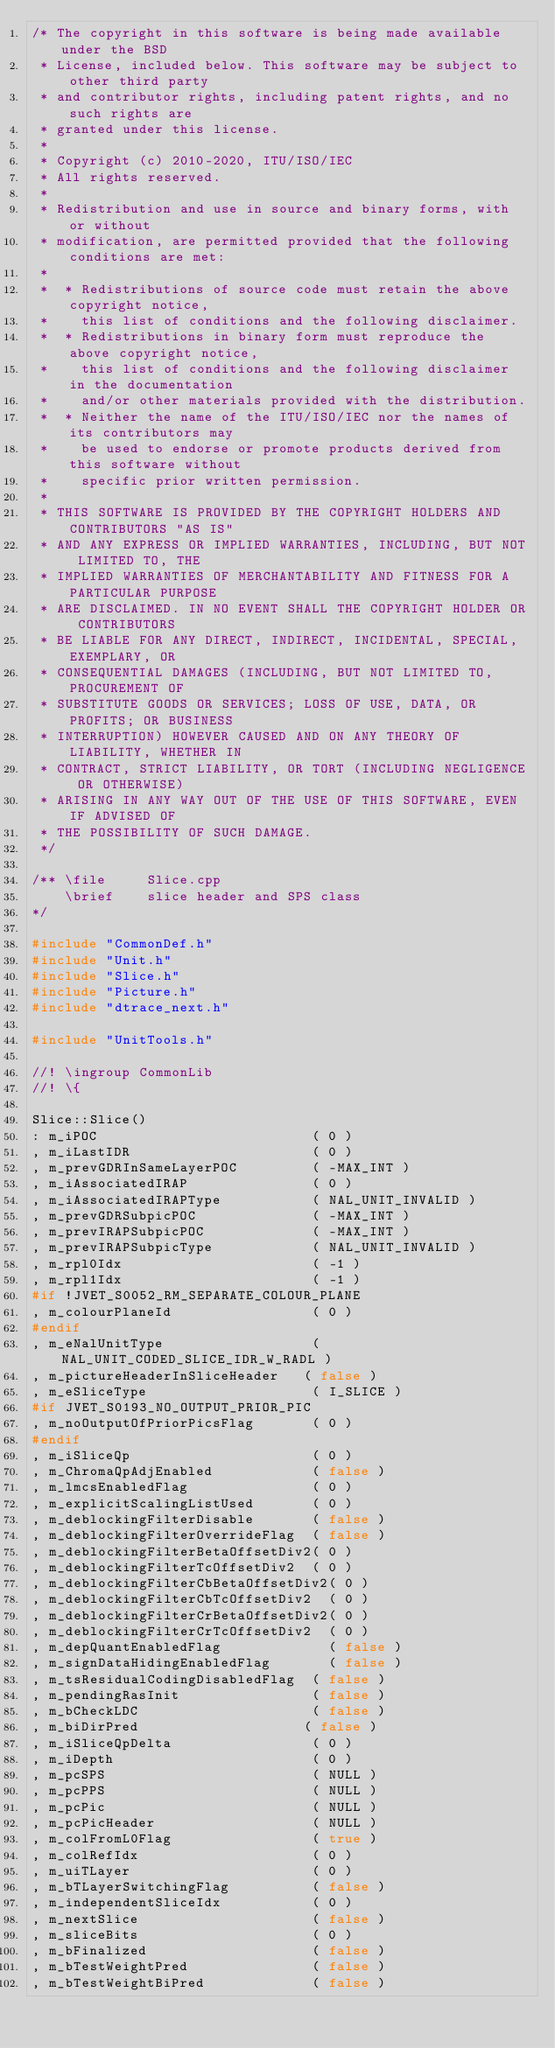<code> <loc_0><loc_0><loc_500><loc_500><_C++_>/* The copyright in this software is being made available under the BSD
 * License, included below. This software may be subject to other third party
 * and contributor rights, including patent rights, and no such rights are
 * granted under this license.
 *
 * Copyright (c) 2010-2020, ITU/ISO/IEC
 * All rights reserved.
 *
 * Redistribution and use in source and binary forms, with or without
 * modification, are permitted provided that the following conditions are met:
 *
 *  * Redistributions of source code must retain the above copyright notice,
 *    this list of conditions and the following disclaimer.
 *  * Redistributions in binary form must reproduce the above copyright notice,
 *    this list of conditions and the following disclaimer in the documentation
 *    and/or other materials provided with the distribution.
 *  * Neither the name of the ITU/ISO/IEC nor the names of its contributors may
 *    be used to endorse or promote products derived from this software without
 *    specific prior written permission.
 *
 * THIS SOFTWARE IS PROVIDED BY THE COPYRIGHT HOLDERS AND CONTRIBUTORS "AS IS"
 * AND ANY EXPRESS OR IMPLIED WARRANTIES, INCLUDING, BUT NOT LIMITED TO, THE
 * IMPLIED WARRANTIES OF MERCHANTABILITY AND FITNESS FOR A PARTICULAR PURPOSE
 * ARE DISCLAIMED. IN NO EVENT SHALL THE COPYRIGHT HOLDER OR CONTRIBUTORS
 * BE LIABLE FOR ANY DIRECT, INDIRECT, INCIDENTAL, SPECIAL, EXEMPLARY, OR
 * CONSEQUENTIAL DAMAGES (INCLUDING, BUT NOT LIMITED TO, PROCUREMENT OF
 * SUBSTITUTE GOODS OR SERVICES; LOSS OF USE, DATA, OR PROFITS; OR BUSINESS
 * INTERRUPTION) HOWEVER CAUSED AND ON ANY THEORY OF LIABILITY, WHETHER IN
 * CONTRACT, STRICT LIABILITY, OR TORT (INCLUDING NEGLIGENCE OR OTHERWISE)
 * ARISING IN ANY WAY OUT OF THE USE OF THIS SOFTWARE, EVEN IF ADVISED OF
 * THE POSSIBILITY OF SUCH DAMAGE.
 */

/** \file     Slice.cpp
    \brief    slice header and SPS class
*/

#include "CommonDef.h"
#include "Unit.h"
#include "Slice.h"
#include "Picture.h"
#include "dtrace_next.h"

#include "UnitTools.h"

//! \ingroup CommonLib
//! \{

Slice::Slice()
: m_iPOC                          ( 0 )
, m_iLastIDR                      ( 0 )
, m_prevGDRInSameLayerPOC         ( -MAX_INT )
, m_iAssociatedIRAP               ( 0 )
, m_iAssociatedIRAPType           ( NAL_UNIT_INVALID )
, m_prevGDRSubpicPOC              ( -MAX_INT )
, m_prevIRAPSubpicPOC             ( -MAX_INT )
, m_prevIRAPSubpicType            ( NAL_UNIT_INVALID )
, m_rpl0Idx                       ( -1 )
, m_rpl1Idx                       ( -1 )
#if !JVET_S0052_RM_SEPARATE_COLOUR_PLANE
, m_colourPlaneId                 ( 0 )
#endif
, m_eNalUnitType                  ( NAL_UNIT_CODED_SLICE_IDR_W_RADL )
, m_pictureHeaderInSliceHeader   ( false )
, m_eSliceType                    ( I_SLICE )
#if JVET_S0193_NO_OUTPUT_PRIOR_PIC
, m_noOutputOfPriorPicsFlag       ( 0 )
#endif
, m_iSliceQp                      ( 0 )
, m_ChromaQpAdjEnabled            ( false )
, m_lmcsEnabledFlag               ( 0 )
, m_explicitScalingListUsed       ( 0 )
, m_deblockingFilterDisable       ( false )
, m_deblockingFilterOverrideFlag  ( false )
, m_deblockingFilterBetaOffsetDiv2( 0 )
, m_deblockingFilterTcOffsetDiv2  ( 0 )
, m_deblockingFilterCbBetaOffsetDiv2( 0 )
, m_deblockingFilterCbTcOffsetDiv2  ( 0 )
, m_deblockingFilterCrBetaOffsetDiv2( 0 )
, m_deblockingFilterCrTcOffsetDiv2  ( 0 )
, m_depQuantEnabledFlag             ( false )
, m_signDataHidingEnabledFlag       ( false )
, m_tsResidualCodingDisabledFlag  ( false )
, m_pendingRasInit                ( false )
, m_bCheckLDC                     ( false )
, m_biDirPred                    ( false )
, m_iSliceQpDelta                 ( 0 )
, m_iDepth                        ( 0 )
, m_pcSPS                         ( NULL )
, m_pcPPS                         ( NULL )
, m_pcPic                         ( NULL )
, m_pcPicHeader                   ( NULL )
, m_colFromL0Flag                 ( true )
, m_colRefIdx                     ( 0 )
, m_uiTLayer                      ( 0 )
, m_bTLayerSwitchingFlag          ( false )
, m_independentSliceIdx           ( 0 )
, m_nextSlice                     ( false )
, m_sliceBits                     ( 0 )
, m_bFinalized                    ( false )
, m_bTestWeightPred               ( false )
, m_bTestWeightBiPred             ( false )</code> 